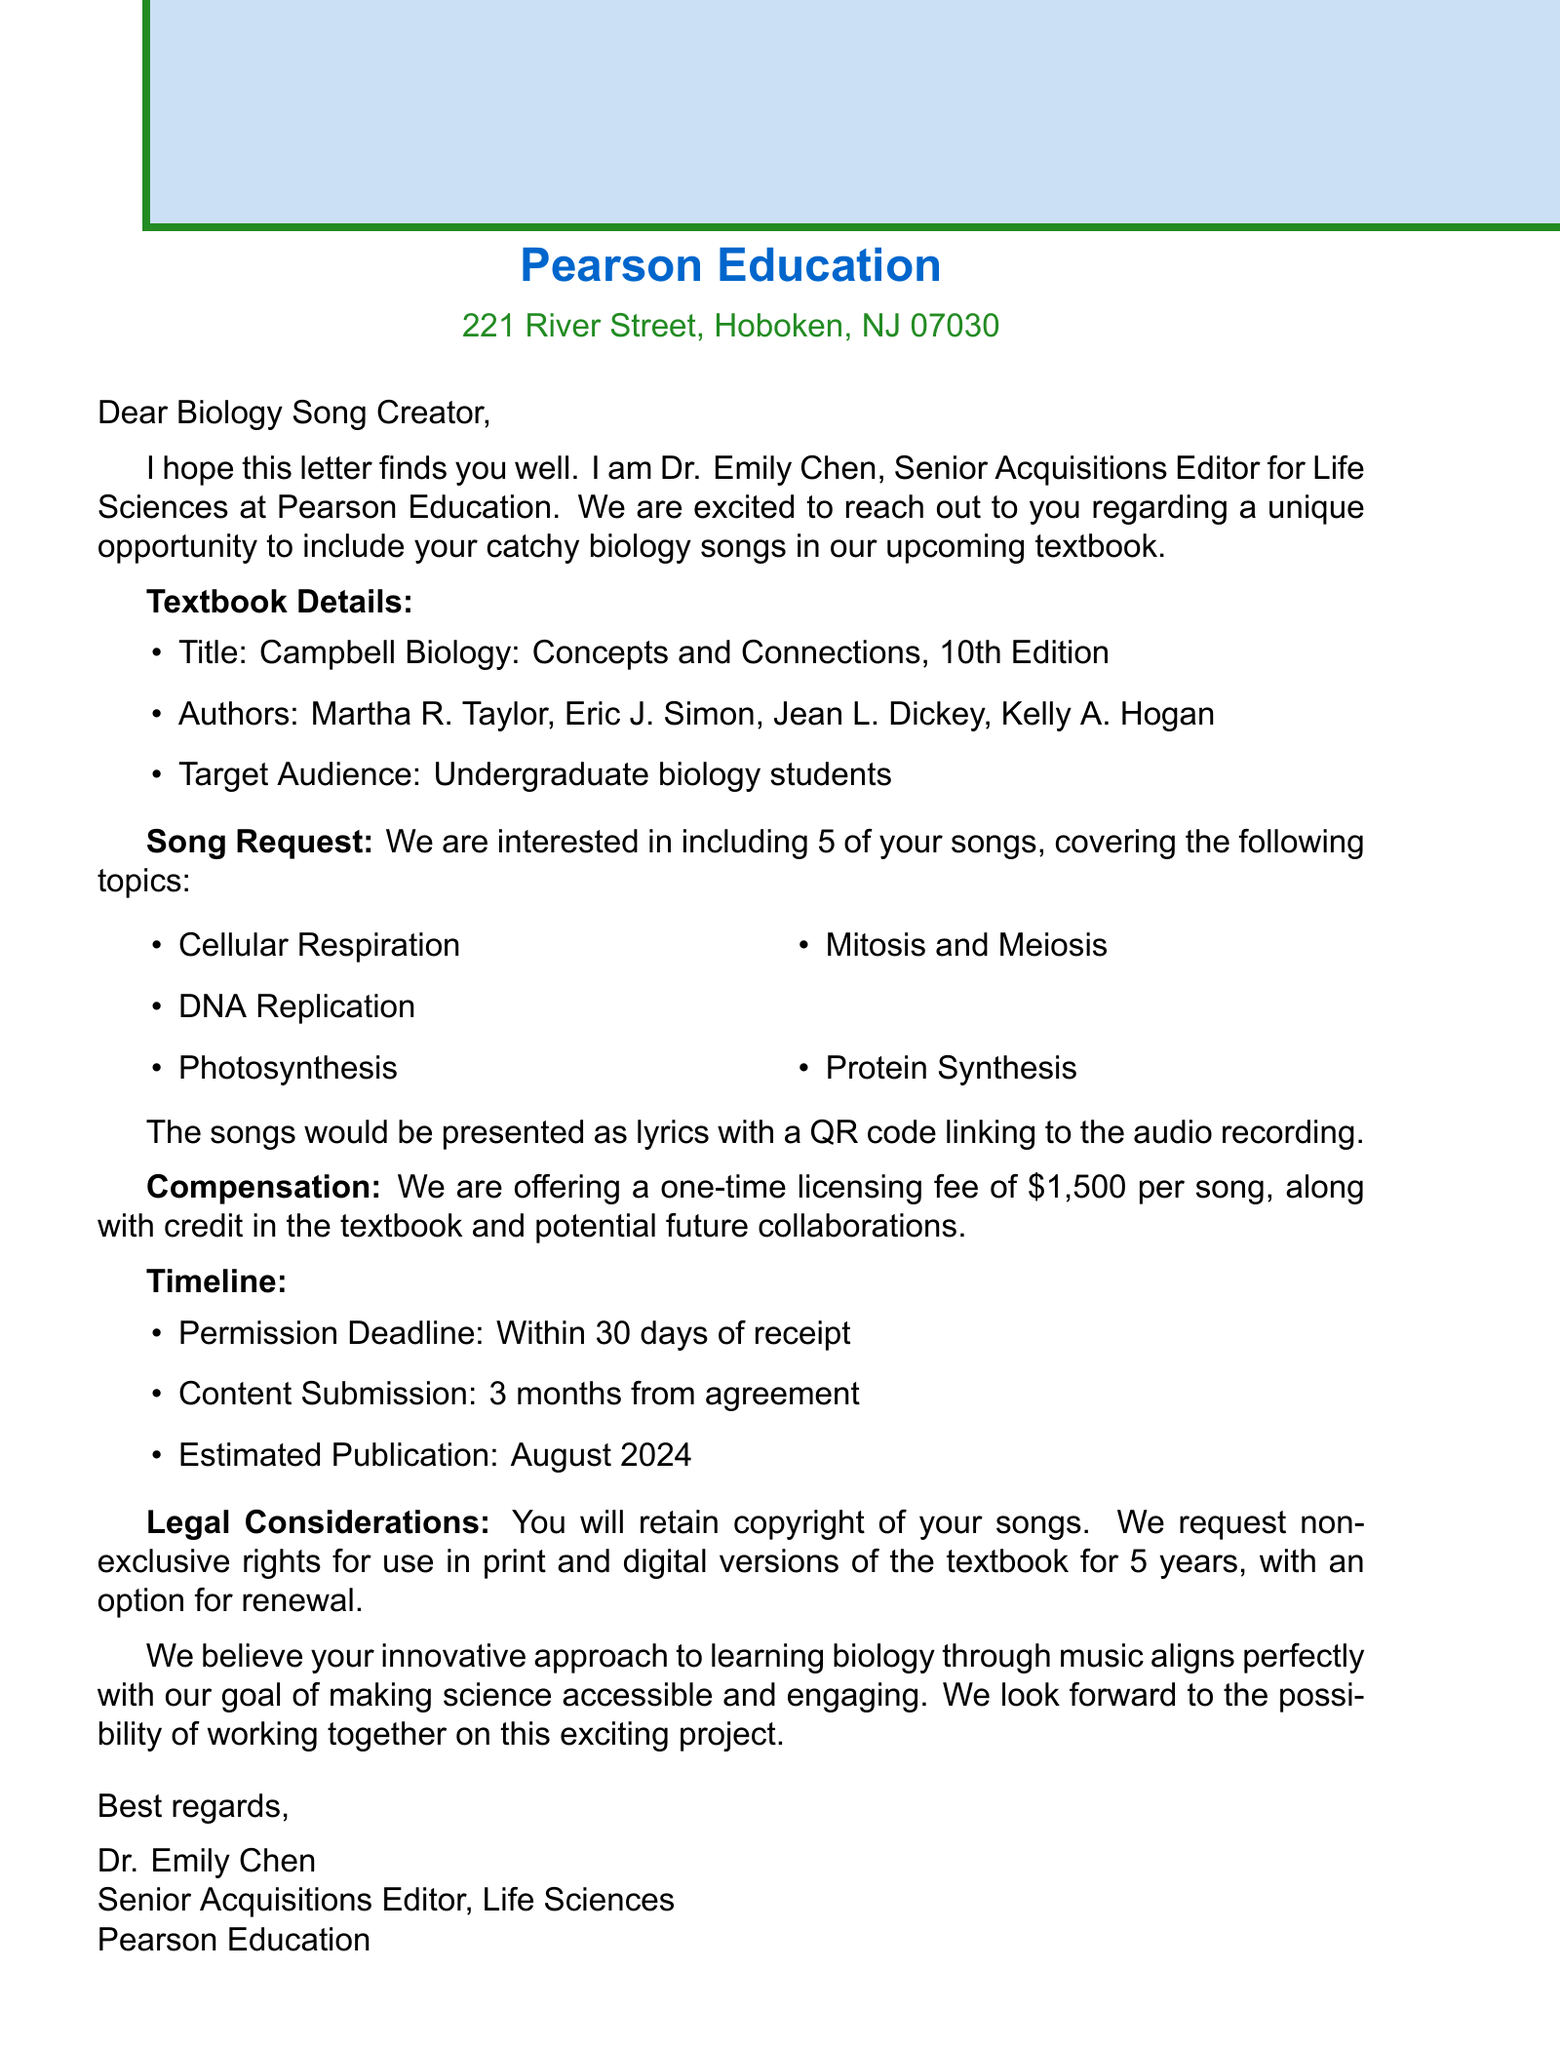What is the name of the publisher? The publisher's name is mentioned at the beginning of the letter.
Answer: Pearson Education Who is the contact person for this request? The contact person's name is given in the introduction of the letter.
Answer: Dr. Emily Chen How many songs are being requested? The document specifies the number of songs requested.
Answer: 5 What is the total compensation offered per song? The letter states the amount offered for each song.
Answer: $1,500 What is the permission deadline? The document specifies the date by which permission must be granted.
Answer: Within 30 days of receipt What are the subjects of the songs requested? The letter lists the topics for the requested songs.
Answer: Cellular Respiration, DNA Replication, Photosynthesis, Mitosis and Meiosis, Protein Synthesis What type of usage rights are being requested? The letter mentions the kind of rights sought for the songs.
Answer: Non-exclusive rights What is the estimated publication date? The letter provides the expected publication timeline.
Answer: August 2024 How long will the contract last? The duration of the contract is mentioned in the legal considerations section.
Answer: 5 years with option for renewal 